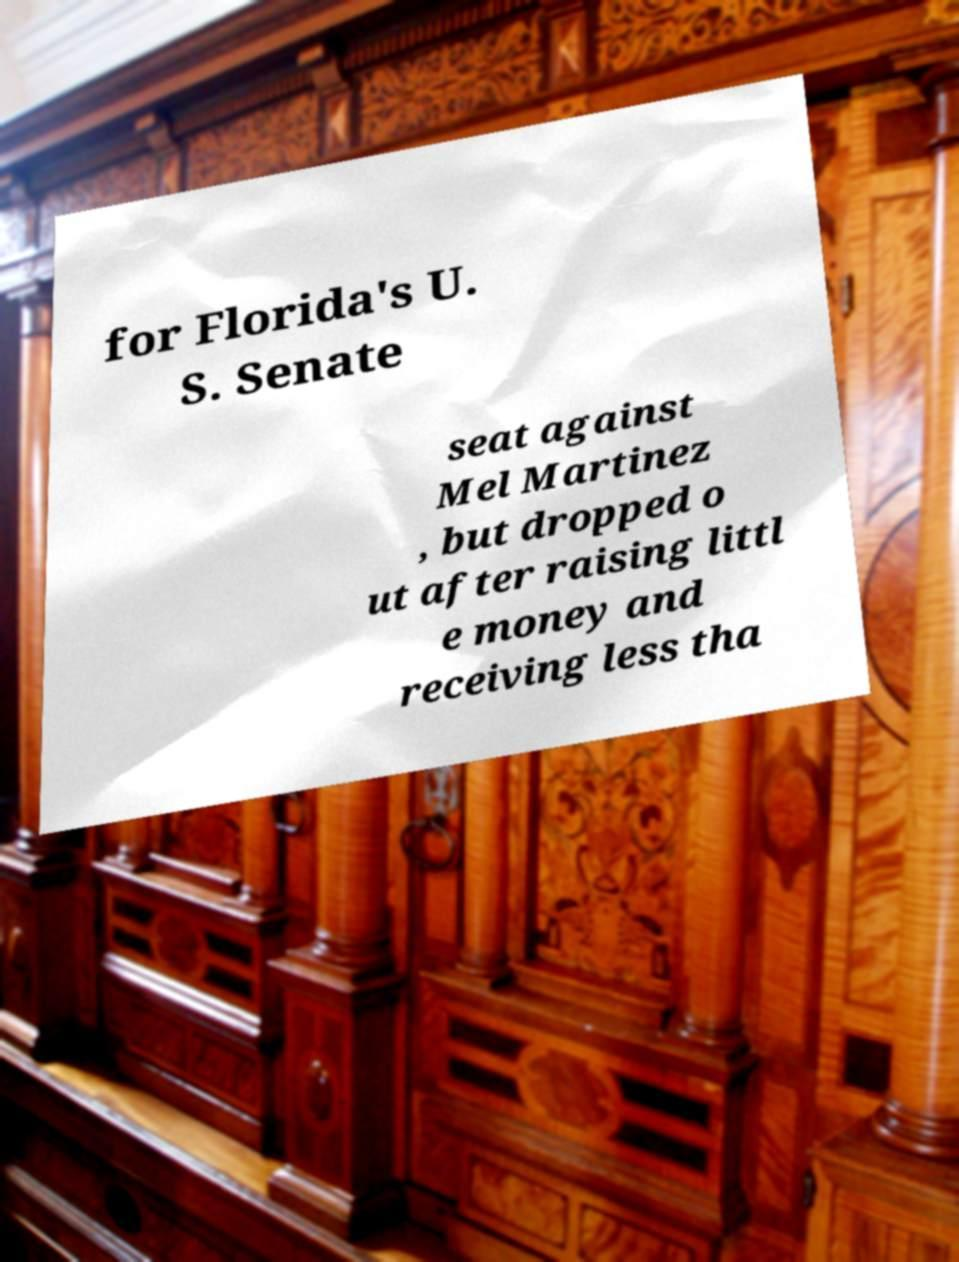I need the written content from this picture converted into text. Can you do that? for Florida's U. S. Senate seat against Mel Martinez , but dropped o ut after raising littl e money and receiving less tha 